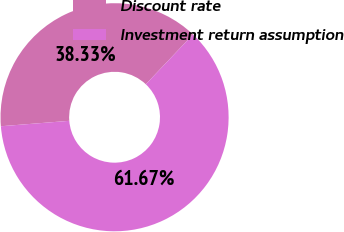<chart> <loc_0><loc_0><loc_500><loc_500><pie_chart><fcel>Discount rate<fcel>Investment return assumption<nl><fcel>38.33%<fcel>61.67%<nl></chart> 